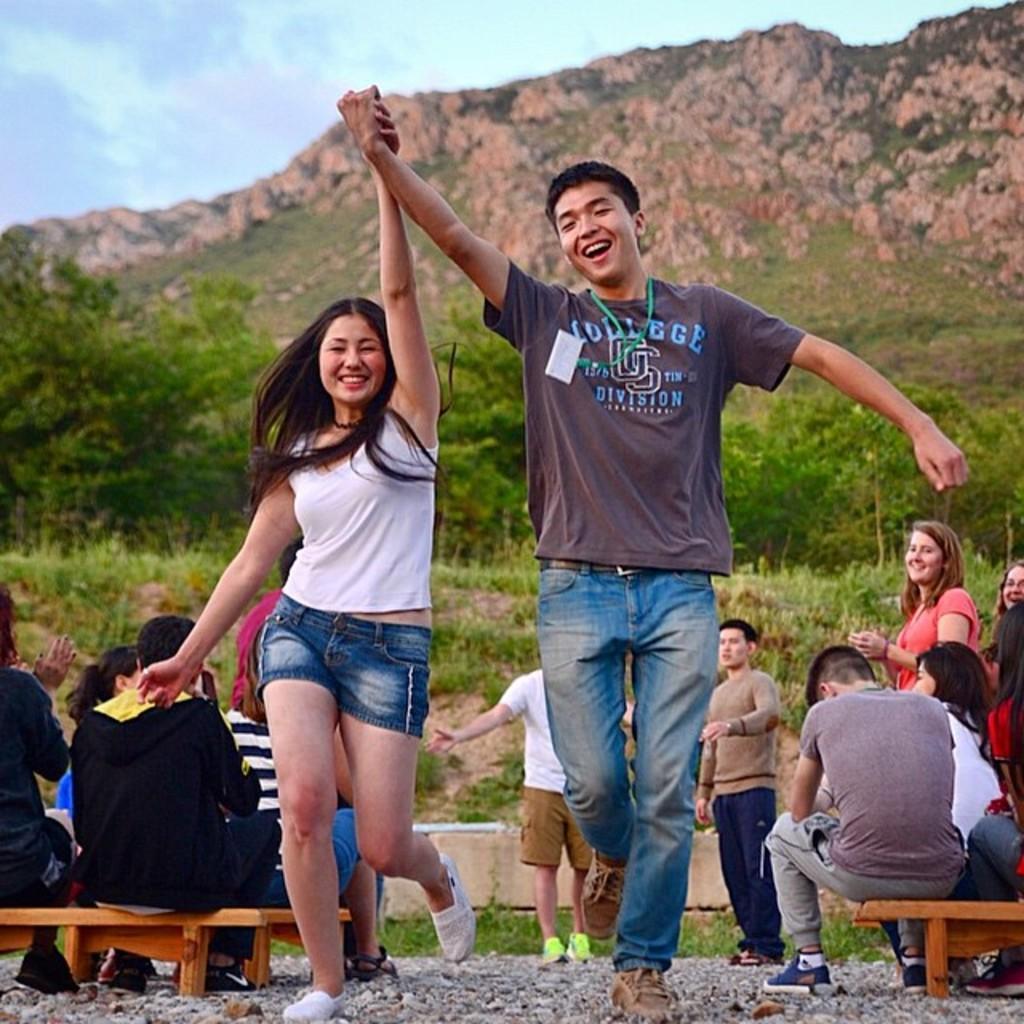How would you summarize this image in a sentence or two? In this image we can see two persons holding hands, one of them is wearing an access card, behind them, we can see a few people, some of them are standing and the some people are sitting on the benches, there are mountains, plants, and trees, also we can see the sky. 